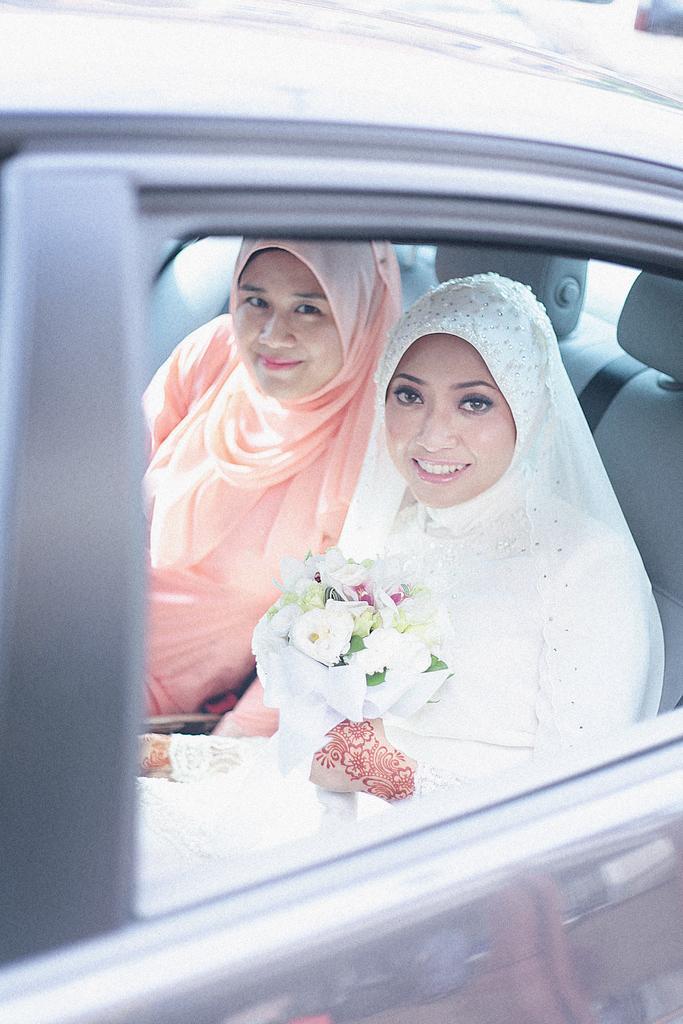Can you describe this image briefly? In this picture we can see two women smiling, sitting on car and here in this woman hands we can see flower bouquet. 